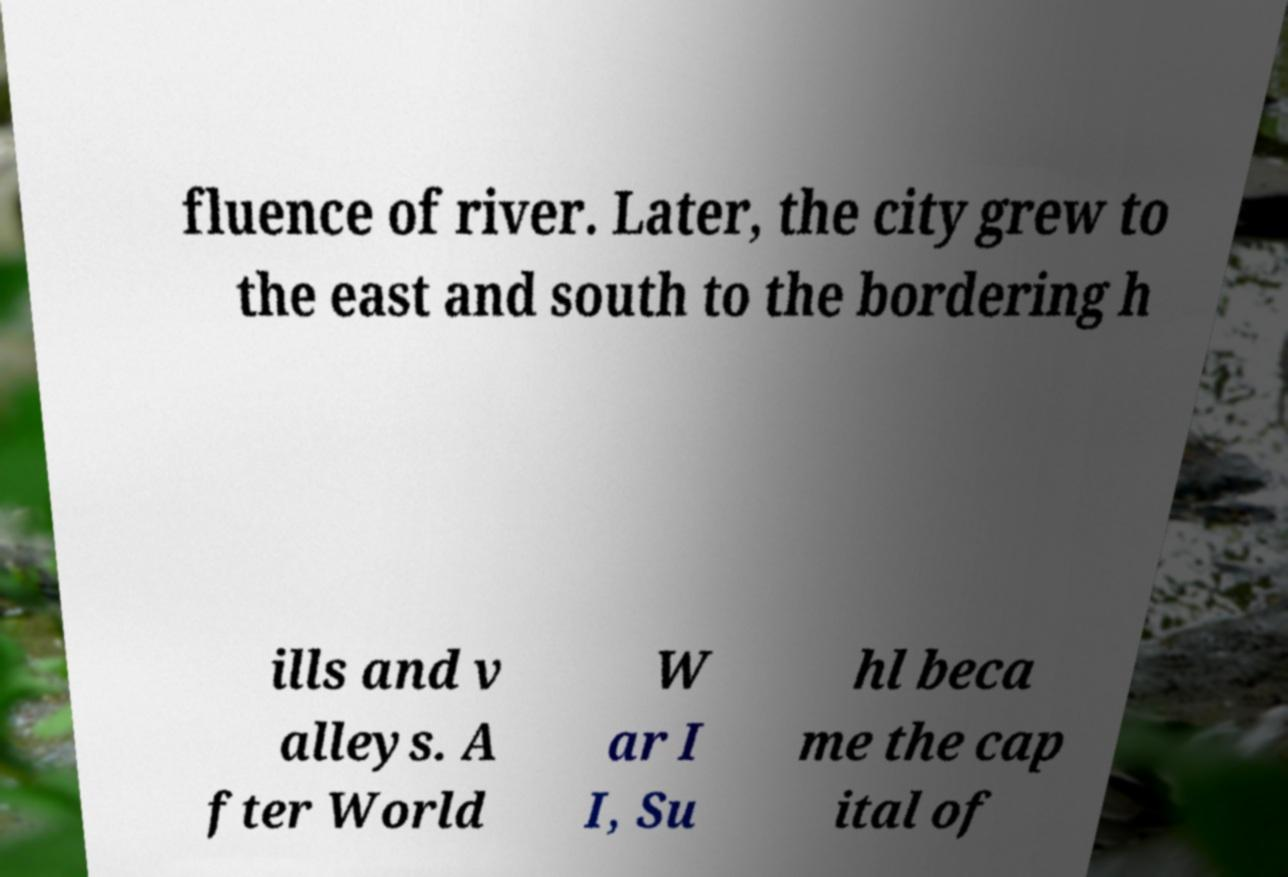Can you accurately transcribe the text from the provided image for me? fluence of river. Later, the city grew to the east and south to the bordering h ills and v alleys. A fter World W ar I I, Su hl beca me the cap ital of 